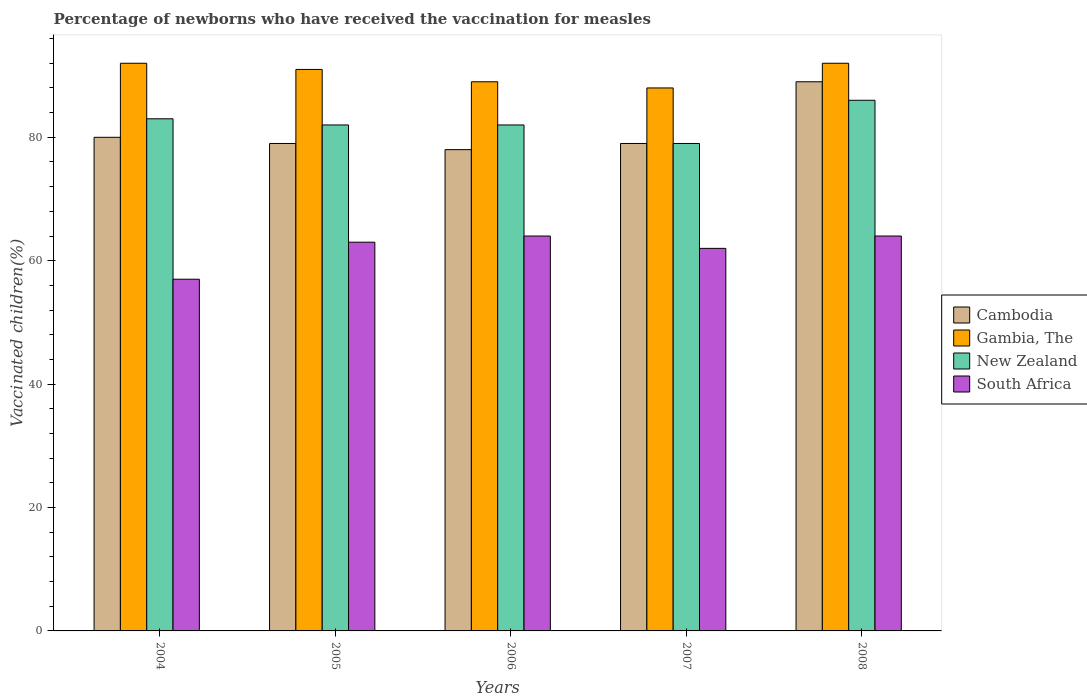How many groups of bars are there?
Provide a short and direct response. 5. Are the number of bars per tick equal to the number of legend labels?
Ensure brevity in your answer.  Yes. How many bars are there on the 3rd tick from the left?
Offer a terse response. 4. How many bars are there on the 1st tick from the right?
Offer a terse response. 4. What is the percentage of vaccinated children in Cambodia in 2006?
Give a very brief answer. 78. Across all years, what is the maximum percentage of vaccinated children in Gambia, The?
Offer a terse response. 92. Across all years, what is the minimum percentage of vaccinated children in New Zealand?
Your answer should be compact. 79. In which year was the percentage of vaccinated children in Gambia, The minimum?
Provide a succinct answer. 2007. What is the total percentage of vaccinated children in New Zealand in the graph?
Your response must be concise. 412. What is the difference between the percentage of vaccinated children in New Zealand in 2005 and that in 2008?
Your answer should be very brief. -4. In how many years, is the percentage of vaccinated children in South Africa greater than 16 %?
Your answer should be compact. 5. What is the ratio of the percentage of vaccinated children in Gambia, The in 2004 to that in 2008?
Give a very brief answer. 1. What is the difference between the highest and the lowest percentage of vaccinated children in New Zealand?
Offer a very short reply. 7. Is the sum of the percentage of vaccinated children in Gambia, The in 2004 and 2006 greater than the maximum percentage of vaccinated children in Cambodia across all years?
Offer a very short reply. Yes. Is it the case that in every year, the sum of the percentage of vaccinated children in Gambia, The and percentage of vaccinated children in Cambodia is greater than the sum of percentage of vaccinated children in South Africa and percentage of vaccinated children in New Zealand?
Offer a terse response. No. What does the 4th bar from the left in 2006 represents?
Provide a short and direct response. South Africa. What does the 4th bar from the right in 2005 represents?
Your response must be concise. Cambodia. What is the difference between two consecutive major ticks on the Y-axis?
Make the answer very short. 20. Are the values on the major ticks of Y-axis written in scientific E-notation?
Provide a succinct answer. No. What is the title of the graph?
Make the answer very short. Percentage of newborns who have received the vaccination for measles. Does "Kiribati" appear as one of the legend labels in the graph?
Keep it short and to the point. No. What is the label or title of the X-axis?
Your answer should be very brief. Years. What is the label or title of the Y-axis?
Keep it short and to the point. Vaccinated children(%). What is the Vaccinated children(%) of Cambodia in 2004?
Your answer should be very brief. 80. What is the Vaccinated children(%) of Gambia, The in 2004?
Give a very brief answer. 92. What is the Vaccinated children(%) in Cambodia in 2005?
Make the answer very short. 79. What is the Vaccinated children(%) of Gambia, The in 2005?
Make the answer very short. 91. What is the Vaccinated children(%) in New Zealand in 2005?
Give a very brief answer. 82. What is the Vaccinated children(%) of Gambia, The in 2006?
Give a very brief answer. 89. What is the Vaccinated children(%) of New Zealand in 2006?
Offer a terse response. 82. What is the Vaccinated children(%) in South Africa in 2006?
Ensure brevity in your answer.  64. What is the Vaccinated children(%) of Cambodia in 2007?
Your response must be concise. 79. What is the Vaccinated children(%) of Gambia, The in 2007?
Provide a succinct answer. 88. What is the Vaccinated children(%) of New Zealand in 2007?
Make the answer very short. 79. What is the Vaccinated children(%) in Cambodia in 2008?
Your answer should be very brief. 89. What is the Vaccinated children(%) in Gambia, The in 2008?
Make the answer very short. 92. Across all years, what is the maximum Vaccinated children(%) in Cambodia?
Give a very brief answer. 89. Across all years, what is the maximum Vaccinated children(%) of Gambia, The?
Provide a short and direct response. 92. Across all years, what is the maximum Vaccinated children(%) of New Zealand?
Offer a terse response. 86. Across all years, what is the minimum Vaccinated children(%) of Cambodia?
Provide a succinct answer. 78. Across all years, what is the minimum Vaccinated children(%) of Gambia, The?
Your answer should be compact. 88. Across all years, what is the minimum Vaccinated children(%) in New Zealand?
Your answer should be compact. 79. What is the total Vaccinated children(%) in Cambodia in the graph?
Give a very brief answer. 405. What is the total Vaccinated children(%) of Gambia, The in the graph?
Make the answer very short. 452. What is the total Vaccinated children(%) in New Zealand in the graph?
Your answer should be compact. 412. What is the total Vaccinated children(%) in South Africa in the graph?
Your response must be concise. 310. What is the difference between the Vaccinated children(%) in Gambia, The in 2004 and that in 2005?
Your answer should be compact. 1. What is the difference between the Vaccinated children(%) of South Africa in 2004 and that in 2005?
Offer a terse response. -6. What is the difference between the Vaccinated children(%) of Cambodia in 2004 and that in 2006?
Your response must be concise. 2. What is the difference between the Vaccinated children(%) in Gambia, The in 2004 and that in 2006?
Offer a very short reply. 3. What is the difference between the Vaccinated children(%) in New Zealand in 2004 and that in 2006?
Make the answer very short. 1. What is the difference between the Vaccinated children(%) in Cambodia in 2004 and that in 2007?
Your response must be concise. 1. What is the difference between the Vaccinated children(%) of Gambia, The in 2004 and that in 2007?
Give a very brief answer. 4. What is the difference between the Vaccinated children(%) of South Africa in 2004 and that in 2007?
Provide a succinct answer. -5. What is the difference between the Vaccinated children(%) in Gambia, The in 2004 and that in 2008?
Make the answer very short. 0. What is the difference between the Vaccinated children(%) of South Africa in 2004 and that in 2008?
Your answer should be very brief. -7. What is the difference between the Vaccinated children(%) of Gambia, The in 2005 and that in 2006?
Keep it short and to the point. 2. What is the difference between the Vaccinated children(%) in Cambodia in 2005 and that in 2007?
Make the answer very short. 0. What is the difference between the Vaccinated children(%) in Gambia, The in 2005 and that in 2007?
Make the answer very short. 3. What is the difference between the Vaccinated children(%) in Cambodia in 2005 and that in 2008?
Ensure brevity in your answer.  -10. What is the difference between the Vaccinated children(%) in Gambia, The in 2005 and that in 2008?
Your response must be concise. -1. What is the difference between the Vaccinated children(%) of South Africa in 2005 and that in 2008?
Provide a short and direct response. -1. What is the difference between the Vaccinated children(%) in Gambia, The in 2006 and that in 2007?
Offer a terse response. 1. What is the difference between the Vaccinated children(%) in New Zealand in 2006 and that in 2007?
Keep it short and to the point. 3. What is the difference between the Vaccinated children(%) in South Africa in 2006 and that in 2007?
Your answer should be very brief. 2. What is the difference between the Vaccinated children(%) in New Zealand in 2006 and that in 2008?
Provide a short and direct response. -4. What is the difference between the Vaccinated children(%) of Cambodia in 2007 and that in 2008?
Offer a very short reply. -10. What is the difference between the Vaccinated children(%) of New Zealand in 2007 and that in 2008?
Provide a short and direct response. -7. What is the difference between the Vaccinated children(%) of South Africa in 2007 and that in 2008?
Keep it short and to the point. -2. What is the difference between the Vaccinated children(%) in Cambodia in 2004 and the Vaccinated children(%) in New Zealand in 2005?
Your answer should be compact. -2. What is the difference between the Vaccinated children(%) of New Zealand in 2004 and the Vaccinated children(%) of South Africa in 2005?
Offer a very short reply. 20. What is the difference between the Vaccinated children(%) in Cambodia in 2004 and the Vaccinated children(%) in New Zealand in 2006?
Give a very brief answer. -2. What is the difference between the Vaccinated children(%) in Gambia, The in 2004 and the Vaccinated children(%) in South Africa in 2006?
Give a very brief answer. 28. What is the difference between the Vaccinated children(%) in Cambodia in 2004 and the Vaccinated children(%) in New Zealand in 2007?
Keep it short and to the point. 1. What is the difference between the Vaccinated children(%) in Cambodia in 2004 and the Vaccinated children(%) in South Africa in 2007?
Ensure brevity in your answer.  18. What is the difference between the Vaccinated children(%) in New Zealand in 2004 and the Vaccinated children(%) in South Africa in 2007?
Ensure brevity in your answer.  21. What is the difference between the Vaccinated children(%) of Cambodia in 2004 and the Vaccinated children(%) of New Zealand in 2008?
Offer a very short reply. -6. What is the difference between the Vaccinated children(%) of Cambodia in 2004 and the Vaccinated children(%) of South Africa in 2008?
Give a very brief answer. 16. What is the difference between the Vaccinated children(%) of Cambodia in 2005 and the Vaccinated children(%) of Gambia, The in 2006?
Provide a succinct answer. -10. What is the difference between the Vaccinated children(%) in Cambodia in 2005 and the Vaccinated children(%) in New Zealand in 2006?
Your answer should be compact. -3. What is the difference between the Vaccinated children(%) of Cambodia in 2005 and the Vaccinated children(%) of Gambia, The in 2007?
Provide a short and direct response. -9. What is the difference between the Vaccinated children(%) of Cambodia in 2005 and the Vaccinated children(%) of New Zealand in 2007?
Offer a very short reply. 0. What is the difference between the Vaccinated children(%) of Gambia, The in 2005 and the Vaccinated children(%) of New Zealand in 2007?
Make the answer very short. 12. What is the difference between the Vaccinated children(%) of Gambia, The in 2005 and the Vaccinated children(%) of South Africa in 2007?
Provide a succinct answer. 29. What is the difference between the Vaccinated children(%) of Cambodia in 2005 and the Vaccinated children(%) of Gambia, The in 2008?
Keep it short and to the point. -13. What is the difference between the Vaccinated children(%) of Gambia, The in 2005 and the Vaccinated children(%) of South Africa in 2008?
Your answer should be very brief. 27. What is the difference between the Vaccinated children(%) in Cambodia in 2006 and the Vaccinated children(%) in New Zealand in 2007?
Ensure brevity in your answer.  -1. What is the difference between the Vaccinated children(%) of Cambodia in 2006 and the Vaccinated children(%) of South Africa in 2007?
Keep it short and to the point. 16. What is the difference between the Vaccinated children(%) of Gambia, The in 2006 and the Vaccinated children(%) of New Zealand in 2007?
Offer a terse response. 10. What is the difference between the Vaccinated children(%) of New Zealand in 2006 and the Vaccinated children(%) of South Africa in 2007?
Make the answer very short. 20. What is the difference between the Vaccinated children(%) of Cambodia in 2006 and the Vaccinated children(%) of Gambia, The in 2008?
Your answer should be very brief. -14. What is the difference between the Vaccinated children(%) of New Zealand in 2006 and the Vaccinated children(%) of South Africa in 2008?
Your answer should be very brief. 18. What is the difference between the Vaccinated children(%) of Cambodia in 2007 and the Vaccinated children(%) of Gambia, The in 2008?
Provide a succinct answer. -13. What is the difference between the Vaccinated children(%) of Cambodia in 2007 and the Vaccinated children(%) of South Africa in 2008?
Give a very brief answer. 15. What is the difference between the Vaccinated children(%) in Gambia, The in 2007 and the Vaccinated children(%) in New Zealand in 2008?
Offer a very short reply. 2. What is the difference between the Vaccinated children(%) of Gambia, The in 2007 and the Vaccinated children(%) of South Africa in 2008?
Provide a succinct answer. 24. What is the difference between the Vaccinated children(%) in New Zealand in 2007 and the Vaccinated children(%) in South Africa in 2008?
Keep it short and to the point. 15. What is the average Vaccinated children(%) in Cambodia per year?
Your answer should be compact. 81. What is the average Vaccinated children(%) in Gambia, The per year?
Give a very brief answer. 90.4. What is the average Vaccinated children(%) of New Zealand per year?
Provide a short and direct response. 82.4. What is the average Vaccinated children(%) in South Africa per year?
Make the answer very short. 62. In the year 2004, what is the difference between the Vaccinated children(%) in Cambodia and Vaccinated children(%) in Gambia, The?
Offer a terse response. -12. In the year 2004, what is the difference between the Vaccinated children(%) of Gambia, The and Vaccinated children(%) of New Zealand?
Your answer should be compact. 9. In the year 2004, what is the difference between the Vaccinated children(%) in Gambia, The and Vaccinated children(%) in South Africa?
Offer a very short reply. 35. In the year 2004, what is the difference between the Vaccinated children(%) of New Zealand and Vaccinated children(%) of South Africa?
Your answer should be compact. 26. In the year 2005, what is the difference between the Vaccinated children(%) in Cambodia and Vaccinated children(%) in Gambia, The?
Offer a terse response. -12. In the year 2005, what is the difference between the Vaccinated children(%) of Cambodia and Vaccinated children(%) of South Africa?
Make the answer very short. 16. In the year 2005, what is the difference between the Vaccinated children(%) of Gambia, The and Vaccinated children(%) of New Zealand?
Offer a very short reply. 9. In the year 2006, what is the difference between the Vaccinated children(%) in Cambodia and Vaccinated children(%) in New Zealand?
Offer a terse response. -4. In the year 2006, what is the difference between the Vaccinated children(%) of Cambodia and Vaccinated children(%) of South Africa?
Provide a succinct answer. 14. In the year 2006, what is the difference between the Vaccinated children(%) of Gambia, The and Vaccinated children(%) of New Zealand?
Ensure brevity in your answer.  7. In the year 2006, what is the difference between the Vaccinated children(%) of Gambia, The and Vaccinated children(%) of South Africa?
Ensure brevity in your answer.  25. In the year 2007, what is the difference between the Vaccinated children(%) of Cambodia and Vaccinated children(%) of Gambia, The?
Offer a terse response. -9. In the year 2007, what is the difference between the Vaccinated children(%) of Cambodia and Vaccinated children(%) of New Zealand?
Make the answer very short. 0. In the year 2007, what is the difference between the Vaccinated children(%) of Cambodia and Vaccinated children(%) of South Africa?
Offer a very short reply. 17. In the year 2007, what is the difference between the Vaccinated children(%) of New Zealand and Vaccinated children(%) of South Africa?
Keep it short and to the point. 17. In the year 2008, what is the difference between the Vaccinated children(%) in Cambodia and Vaccinated children(%) in South Africa?
Make the answer very short. 25. In the year 2008, what is the difference between the Vaccinated children(%) of Gambia, The and Vaccinated children(%) of South Africa?
Keep it short and to the point. 28. In the year 2008, what is the difference between the Vaccinated children(%) of New Zealand and Vaccinated children(%) of South Africa?
Keep it short and to the point. 22. What is the ratio of the Vaccinated children(%) in Cambodia in 2004 to that in 2005?
Keep it short and to the point. 1.01. What is the ratio of the Vaccinated children(%) of New Zealand in 2004 to that in 2005?
Your answer should be compact. 1.01. What is the ratio of the Vaccinated children(%) in South Africa in 2004 to that in 2005?
Make the answer very short. 0.9. What is the ratio of the Vaccinated children(%) of Cambodia in 2004 to that in 2006?
Your response must be concise. 1.03. What is the ratio of the Vaccinated children(%) of Gambia, The in 2004 to that in 2006?
Ensure brevity in your answer.  1.03. What is the ratio of the Vaccinated children(%) of New Zealand in 2004 to that in 2006?
Your answer should be compact. 1.01. What is the ratio of the Vaccinated children(%) in South Africa in 2004 to that in 2006?
Ensure brevity in your answer.  0.89. What is the ratio of the Vaccinated children(%) in Cambodia in 2004 to that in 2007?
Offer a very short reply. 1.01. What is the ratio of the Vaccinated children(%) of Gambia, The in 2004 to that in 2007?
Give a very brief answer. 1.05. What is the ratio of the Vaccinated children(%) of New Zealand in 2004 to that in 2007?
Ensure brevity in your answer.  1.05. What is the ratio of the Vaccinated children(%) in South Africa in 2004 to that in 2007?
Your answer should be compact. 0.92. What is the ratio of the Vaccinated children(%) in Cambodia in 2004 to that in 2008?
Offer a terse response. 0.9. What is the ratio of the Vaccinated children(%) of New Zealand in 2004 to that in 2008?
Keep it short and to the point. 0.97. What is the ratio of the Vaccinated children(%) in South Africa in 2004 to that in 2008?
Your response must be concise. 0.89. What is the ratio of the Vaccinated children(%) in Cambodia in 2005 to that in 2006?
Offer a very short reply. 1.01. What is the ratio of the Vaccinated children(%) in Gambia, The in 2005 to that in 2006?
Offer a terse response. 1.02. What is the ratio of the Vaccinated children(%) of New Zealand in 2005 to that in 2006?
Provide a succinct answer. 1. What is the ratio of the Vaccinated children(%) of South Africa in 2005 to that in 2006?
Give a very brief answer. 0.98. What is the ratio of the Vaccinated children(%) in Cambodia in 2005 to that in 2007?
Ensure brevity in your answer.  1. What is the ratio of the Vaccinated children(%) of Gambia, The in 2005 to that in 2007?
Your response must be concise. 1.03. What is the ratio of the Vaccinated children(%) of New Zealand in 2005 to that in 2007?
Provide a short and direct response. 1.04. What is the ratio of the Vaccinated children(%) in South Africa in 2005 to that in 2007?
Your response must be concise. 1.02. What is the ratio of the Vaccinated children(%) of Cambodia in 2005 to that in 2008?
Offer a very short reply. 0.89. What is the ratio of the Vaccinated children(%) in Gambia, The in 2005 to that in 2008?
Your response must be concise. 0.99. What is the ratio of the Vaccinated children(%) in New Zealand in 2005 to that in 2008?
Offer a terse response. 0.95. What is the ratio of the Vaccinated children(%) in South Africa in 2005 to that in 2008?
Ensure brevity in your answer.  0.98. What is the ratio of the Vaccinated children(%) of Cambodia in 2006 to that in 2007?
Your answer should be compact. 0.99. What is the ratio of the Vaccinated children(%) in Gambia, The in 2006 to that in 2007?
Your response must be concise. 1.01. What is the ratio of the Vaccinated children(%) of New Zealand in 2006 to that in 2007?
Provide a succinct answer. 1.04. What is the ratio of the Vaccinated children(%) of South Africa in 2006 to that in 2007?
Your response must be concise. 1.03. What is the ratio of the Vaccinated children(%) of Cambodia in 2006 to that in 2008?
Ensure brevity in your answer.  0.88. What is the ratio of the Vaccinated children(%) of Gambia, The in 2006 to that in 2008?
Give a very brief answer. 0.97. What is the ratio of the Vaccinated children(%) of New Zealand in 2006 to that in 2008?
Make the answer very short. 0.95. What is the ratio of the Vaccinated children(%) in South Africa in 2006 to that in 2008?
Ensure brevity in your answer.  1. What is the ratio of the Vaccinated children(%) in Cambodia in 2007 to that in 2008?
Make the answer very short. 0.89. What is the ratio of the Vaccinated children(%) of Gambia, The in 2007 to that in 2008?
Offer a terse response. 0.96. What is the ratio of the Vaccinated children(%) in New Zealand in 2007 to that in 2008?
Your answer should be compact. 0.92. What is the ratio of the Vaccinated children(%) of South Africa in 2007 to that in 2008?
Your response must be concise. 0.97. What is the difference between the highest and the second highest Vaccinated children(%) in Cambodia?
Your answer should be very brief. 9. What is the difference between the highest and the second highest Vaccinated children(%) in Gambia, The?
Ensure brevity in your answer.  0. What is the difference between the highest and the second highest Vaccinated children(%) of New Zealand?
Your response must be concise. 3. What is the difference between the highest and the lowest Vaccinated children(%) of New Zealand?
Provide a short and direct response. 7. 